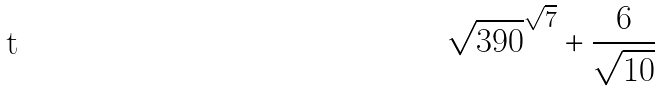Convert formula to latex. <formula><loc_0><loc_0><loc_500><loc_500>\sqrt { 3 9 0 } ^ { \sqrt { 7 } } + \frac { 6 } { \sqrt { 1 0 } }</formula> 